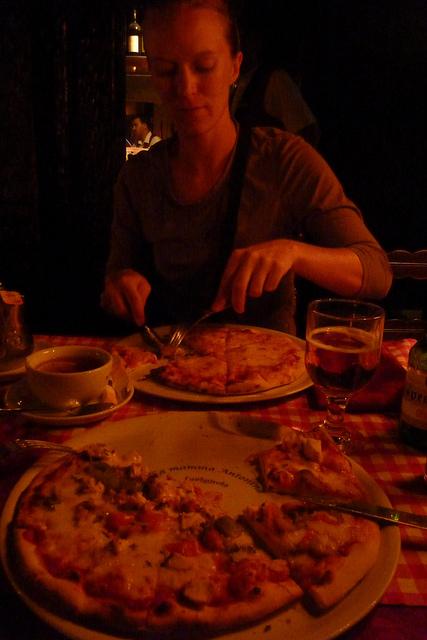Is the woman wearing jewelry?
Give a very brief answer. No. Is this a vegan meal?
Concise answer only. No. Is this person sitting at a table?
Concise answer only. Yes. What is the woman doing?
Give a very brief answer. Eating. Does the food appear to be sweet or savory in nature?
Answer briefly. Savory. How many people are at the table?
Answer briefly. 1. 